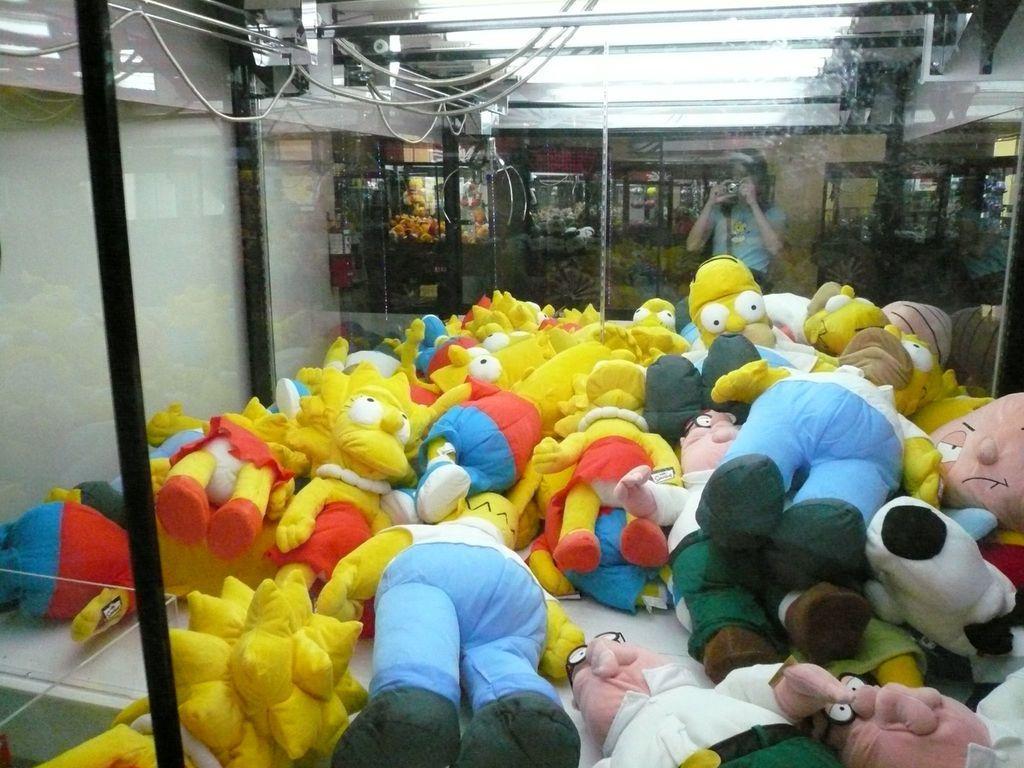Describe this image in one or two sentences. In the image we can see some toys. Behind the toys there is a glass wall, through the glass wall we can see a person is standing and holding something in her hand. 